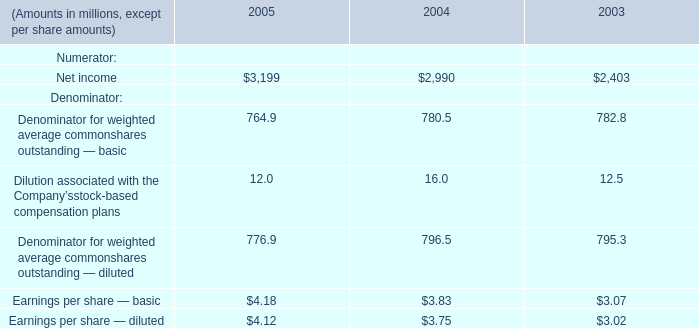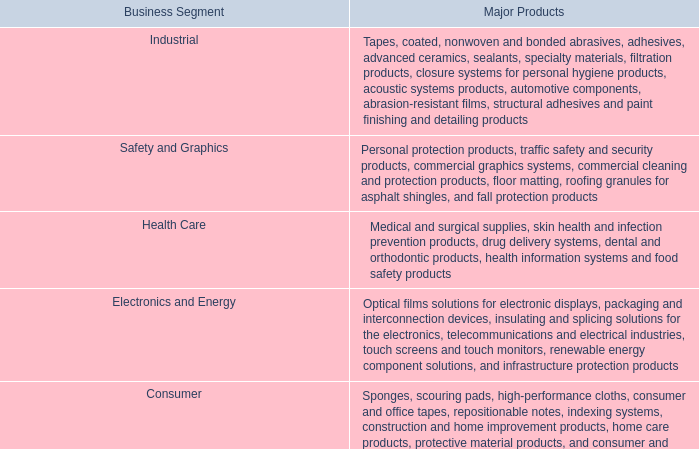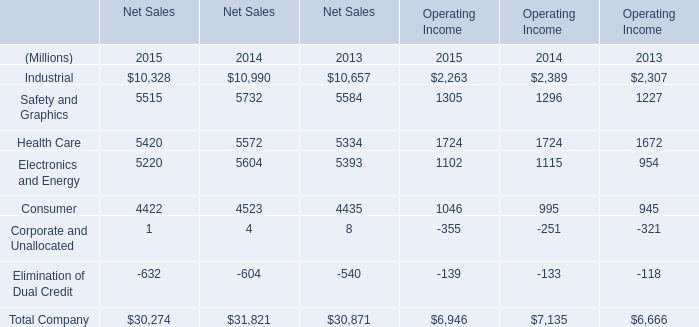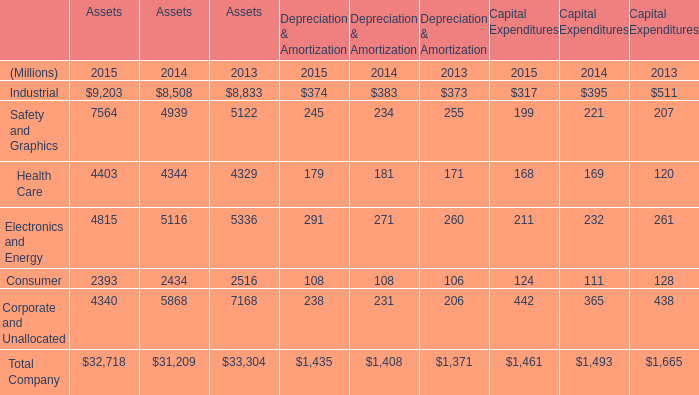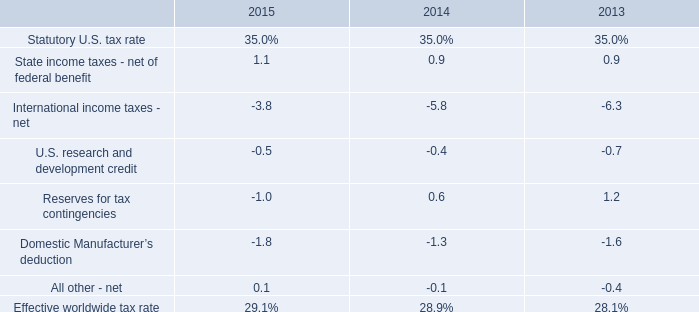What was the total amount of Industrial greater than 8000 for Assets ? (in Million) 
Computations: ((9203 + 8508) + 8833)
Answer: 26544.0. 